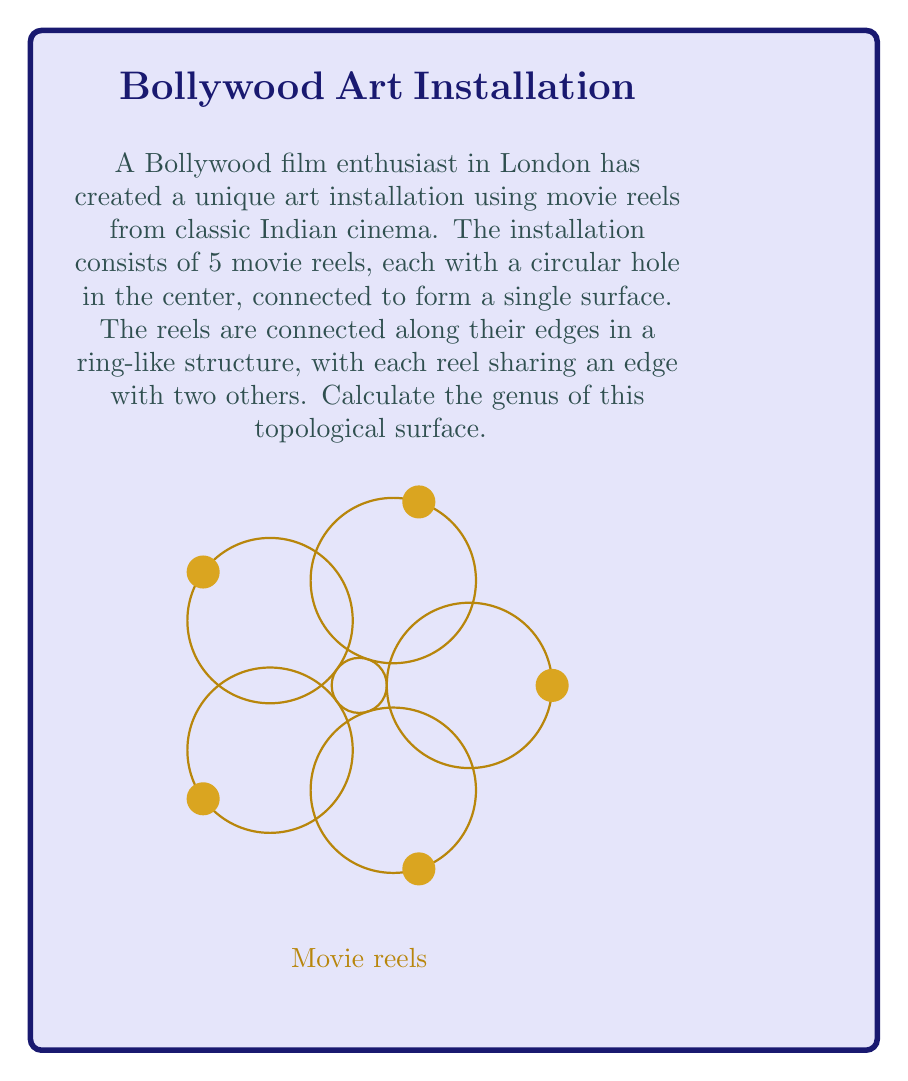What is the answer to this math problem? To calculate the genus of this surface, we'll follow these steps:

1) First, let's recall the Euler characteristic formula for a surface:
   
   $$\chi = V - E + F$$
   
   where $\chi$ is the Euler characteristic, $V$ is the number of vertices, $E$ is the number of edges, and $F$ is the number of faces.

2) In our movie reel structure:
   - Vertices (V): There are no distinct vertices in this structure.
   - Edges (E): Each reel shares an edge with two others, so there are 5 edges.
   - Faces (F): We have 5 faces from the movie reels, plus 2 additional faces (one inside the ring and one outside), totaling 7 faces.

3) Let's calculate the Euler characteristic:

   $$\chi = 0 - 5 + 7 = 2$$

4) Now, we can use the relationship between Euler characteristic and genus for a closed, orientable surface:

   $$\chi = 2 - 2g$$

   where $g$ is the genus.

5) Substituting our calculated Euler characteristic:

   $$2 = 2 - 2g$$

6) Solving for $g$:

   $$2g = 0$$
   $$g = 0$$

Therefore, the genus of this surface is 0, which means it is topologically equivalent to a sphere.
Answer: $g = 0$ 